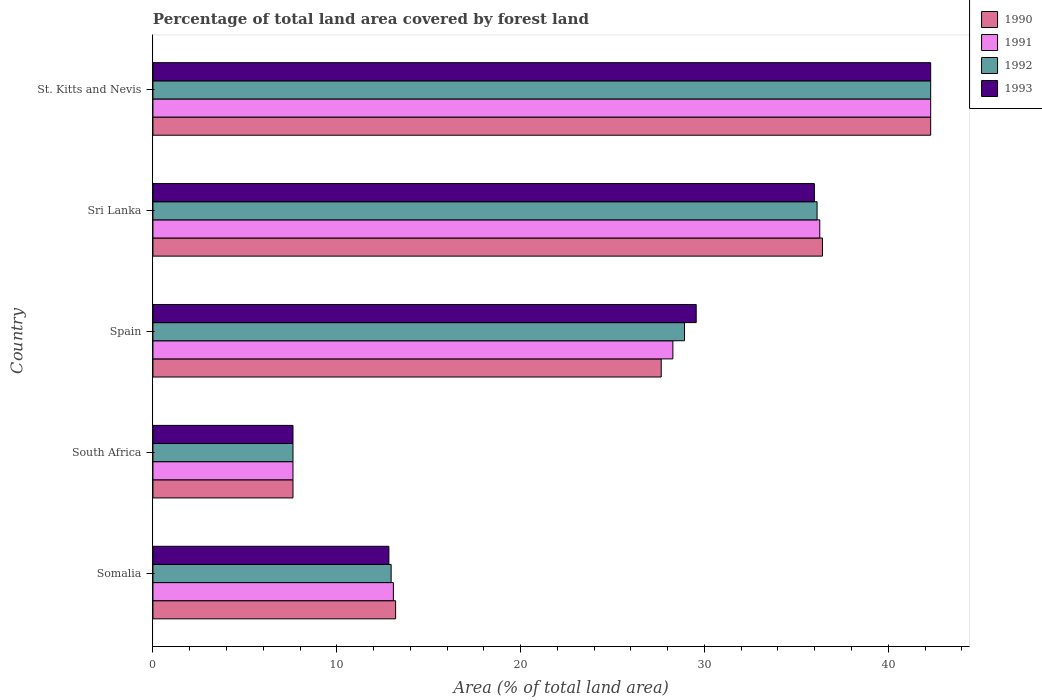How many bars are there on the 3rd tick from the bottom?
Keep it short and to the point. 4. What is the label of the 2nd group of bars from the top?
Your response must be concise. Sri Lanka. In how many cases, is the number of bars for a given country not equal to the number of legend labels?
Provide a succinct answer. 0. What is the percentage of forest land in 1992 in South Africa?
Provide a short and direct response. 7.62. Across all countries, what is the maximum percentage of forest land in 1990?
Give a very brief answer. 42.31. Across all countries, what is the minimum percentage of forest land in 1991?
Your response must be concise. 7.62. In which country was the percentage of forest land in 1990 maximum?
Provide a short and direct response. St. Kitts and Nevis. In which country was the percentage of forest land in 1990 minimum?
Provide a short and direct response. South Africa. What is the total percentage of forest land in 1992 in the graph?
Offer a very short reply. 127.93. What is the difference between the percentage of forest land in 1993 in Sri Lanka and that in St. Kitts and Nevis?
Provide a short and direct response. -6.33. What is the difference between the percentage of forest land in 1992 in Sri Lanka and the percentage of forest land in 1991 in South Africa?
Your answer should be very brief. 28.51. What is the average percentage of forest land in 1990 per country?
Provide a short and direct response. 25.44. What is the difference between the percentage of forest land in 1993 and percentage of forest land in 1990 in Sri Lanka?
Your response must be concise. -0.44. In how many countries, is the percentage of forest land in 1993 greater than 20 %?
Your answer should be very brief. 3. What is the ratio of the percentage of forest land in 1991 in Spain to that in St. Kitts and Nevis?
Give a very brief answer. 0.67. Is the percentage of forest land in 1990 in South Africa less than that in Sri Lanka?
Give a very brief answer. Yes. What is the difference between the highest and the second highest percentage of forest land in 1992?
Offer a very short reply. 6.18. What is the difference between the highest and the lowest percentage of forest land in 1992?
Your answer should be compact. 34.69. In how many countries, is the percentage of forest land in 1990 greater than the average percentage of forest land in 1990 taken over all countries?
Provide a succinct answer. 3. Is the sum of the percentage of forest land in 1992 in South Africa and St. Kitts and Nevis greater than the maximum percentage of forest land in 1993 across all countries?
Provide a succinct answer. Yes. Is it the case that in every country, the sum of the percentage of forest land in 1993 and percentage of forest land in 1991 is greater than the sum of percentage of forest land in 1992 and percentage of forest land in 1990?
Your answer should be very brief. No. What does the 4th bar from the bottom in Sri Lanka represents?
Give a very brief answer. 1993. Is it the case that in every country, the sum of the percentage of forest land in 1991 and percentage of forest land in 1992 is greater than the percentage of forest land in 1993?
Offer a very short reply. Yes. How many bars are there?
Your answer should be compact. 20. How many countries are there in the graph?
Ensure brevity in your answer.  5. What is the difference between two consecutive major ticks on the X-axis?
Give a very brief answer. 10. Are the values on the major ticks of X-axis written in scientific E-notation?
Provide a short and direct response. No. Does the graph contain grids?
Offer a very short reply. No. What is the title of the graph?
Your response must be concise. Percentage of total land area covered by forest land. Does "1971" appear as one of the legend labels in the graph?
Provide a succinct answer. No. What is the label or title of the X-axis?
Ensure brevity in your answer.  Area (% of total land area). What is the label or title of the Y-axis?
Offer a terse response. Country. What is the Area (% of total land area) of 1990 in Somalia?
Offer a terse response. 13.2. What is the Area (% of total land area) of 1991 in Somalia?
Ensure brevity in your answer.  13.08. What is the Area (% of total land area) in 1992 in Somalia?
Keep it short and to the point. 12.96. What is the Area (% of total land area) of 1993 in Somalia?
Your response must be concise. 12.83. What is the Area (% of total land area) in 1990 in South Africa?
Keep it short and to the point. 7.62. What is the Area (% of total land area) of 1991 in South Africa?
Offer a very short reply. 7.62. What is the Area (% of total land area) in 1992 in South Africa?
Make the answer very short. 7.62. What is the Area (% of total land area) of 1993 in South Africa?
Give a very brief answer. 7.62. What is the Area (% of total land area) in 1990 in Spain?
Offer a terse response. 27.65. What is the Area (% of total land area) in 1991 in Spain?
Offer a terse response. 28.28. What is the Area (% of total land area) in 1992 in Spain?
Offer a terse response. 28.92. What is the Area (% of total land area) of 1993 in Spain?
Make the answer very short. 29.55. What is the Area (% of total land area) in 1990 in Sri Lanka?
Provide a succinct answer. 36.42. What is the Area (% of total land area) of 1991 in Sri Lanka?
Give a very brief answer. 36.27. What is the Area (% of total land area) in 1992 in Sri Lanka?
Give a very brief answer. 36.13. What is the Area (% of total land area) in 1993 in Sri Lanka?
Your answer should be compact. 35.98. What is the Area (% of total land area) of 1990 in St. Kitts and Nevis?
Your answer should be compact. 42.31. What is the Area (% of total land area) of 1991 in St. Kitts and Nevis?
Provide a short and direct response. 42.31. What is the Area (% of total land area) in 1992 in St. Kitts and Nevis?
Offer a terse response. 42.31. What is the Area (% of total land area) of 1993 in St. Kitts and Nevis?
Keep it short and to the point. 42.31. Across all countries, what is the maximum Area (% of total land area) of 1990?
Your answer should be compact. 42.31. Across all countries, what is the maximum Area (% of total land area) in 1991?
Your answer should be compact. 42.31. Across all countries, what is the maximum Area (% of total land area) of 1992?
Give a very brief answer. 42.31. Across all countries, what is the maximum Area (% of total land area) of 1993?
Give a very brief answer. 42.31. Across all countries, what is the minimum Area (% of total land area) in 1990?
Provide a succinct answer. 7.62. Across all countries, what is the minimum Area (% of total land area) in 1991?
Offer a very short reply. 7.62. Across all countries, what is the minimum Area (% of total land area) in 1992?
Ensure brevity in your answer.  7.62. Across all countries, what is the minimum Area (% of total land area) of 1993?
Make the answer very short. 7.62. What is the total Area (% of total land area) of 1990 in the graph?
Ensure brevity in your answer.  127.2. What is the total Area (% of total land area) of 1991 in the graph?
Give a very brief answer. 127.56. What is the total Area (% of total land area) in 1992 in the graph?
Give a very brief answer. 127.93. What is the total Area (% of total land area) of 1993 in the graph?
Keep it short and to the point. 128.29. What is the difference between the Area (% of total land area) in 1990 in Somalia and that in South Africa?
Your answer should be very brief. 5.58. What is the difference between the Area (% of total land area) in 1991 in Somalia and that in South Africa?
Provide a succinct answer. 5.46. What is the difference between the Area (% of total land area) in 1992 in Somalia and that in South Africa?
Your answer should be compact. 5.34. What is the difference between the Area (% of total land area) in 1993 in Somalia and that in South Africa?
Provide a short and direct response. 5.22. What is the difference between the Area (% of total land area) in 1990 in Somalia and that in Spain?
Give a very brief answer. -14.45. What is the difference between the Area (% of total land area) in 1991 in Somalia and that in Spain?
Your response must be concise. -15.2. What is the difference between the Area (% of total land area) in 1992 in Somalia and that in Spain?
Ensure brevity in your answer.  -15.96. What is the difference between the Area (% of total land area) in 1993 in Somalia and that in Spain?
Your response must be concise. -16.72. What is the difference between the Area (% of total land area) of 1990 in Somalia and that in Sri Lanka?
Your answer should be very brief. -23.22. What is the difference between the Area (% of total land area) of 1991 in Somalia and that in Sri Lanka?
Make the answer very short. -23.2. What is the difference between the Area (% of total land area) of 1992 in Somalia and that in Sri Lanka?
Offer a terse response. -23.17. What is the difference between the Area (% of total land area) of 1993 in Somalia and that in Sri Lanka?
Your answer should be very brief. -23.15. What is the difference between the Area (% of total land area) in 1990 in Somalia and that in St. Kitts and Nevis?
Your answer should be very brief. -29.11. What is the difference between the Area (% of total land area) of 1991 in Somalia and that in St. Kitts and Nevis?
Offer a terse response. -29.23. What is the difference between the Area (% of total land area) in 1992 in Somalia and that in St. Kitts and Nevis?
Keep it short and to the point. -29.35. What is the difference between the Area (% of total land area) in 1993 in Somalia and that in St. Kitts and Nevis?
Make the answer very short. -29.47. What is the difference between the Area (% of total land area) of 1990 in South Africa and that in Spain?
Your response must be concise. -20.03. What is the difference between the Area (% of total land area) of 1991 in South Africa and that in Spain?
Give a very brief answer. -20.67. What is the difference between the Area (% of total land area) in 1992 in South Africa and that in Spain?
Your answer should be compact. -21.3. What is the difference between the Area (% of total land area) in 1993 in South Africa and that in Spain?
Make the answer very short. -21.93. What is the difference between the Area (% of total land area) of 1990 in South Africa and that in Sri Lanka?
Your answer should be very brief. -28.8. What is the difference between the Area (% of total land area) in 1991 in South Africa and that in Sri Lanka?
Give a very brief answer. -28.66. What is the difference between the Area (% of total land area) in 1992 in South Africa and that in Sri Lanka?
Keep it short and to the point. -28.51. What is the difference between the Area (% of total land area) in 1993 in South Africa and that in Sri Lanka?
Your response must be concise. -28.36. What is the difference between the Area (% of total land area) in 1990 in South Africa and that in St. Kitts and Nevis?
Ensure brevity in your answer.  -34.69. What is the difference between the Area (% of total land area) of 1991 in South Africa and that in St. Kitts and Nevis?
Your answer should be compact. -34.69. What is the difference between the Area (% of total land area) of 1992 in South Africa and that in St. Kitts and Nevis?
Ensure brevity in your answer.  -34.69. What is the difference between the Area (% of total land area) of 1993 in South Africa and that in St. Kitts and Nevis?
Your answer should be compact. -34.69. What is the difference between the Area (% of total land area) in 1990 in Spain and that in Sri Lanka?
Your response must be concise. -8.77. What is the difference between the Area (% of total land area) in 1991 in Spain and that in Sri Lanka?
Offer a very short reply. -7.99. What is the difference between the Area (% of total land area) of 1992 in Spain and that in Sri Lanka?
Make the answer very short. -7.21. What is the difference between the Area (% of total land area) in 1993 in Spain and that in Sri Lanka?
Ensure brevity in your answer.  -6.43. What is the difference between the Area (% of total land area) of 1990 in Spain and that in St. Kitts and Nevis?
Offer a terse response. -14.66. What is the difference between the Area (% of total land area) in 1991 in Spain and that in St. Kitts and Nevis?
Keep it short and to the point. -14.02. What is the difference between the Area (% of total land area) in 1992 in Spain and that in St. Kitts and Nevis?
Your response must be concise. -13.39. What is the difference between the Area (% of total land area) in 1993 in Spain and that in St. Kitts and Nevis?
Offer a terse response. -12.76. What is the difference between the Area (% of total land area) of 1990 in Sri Lanka and that in St. Kitts and Nevis?
Offer a terse response. -5.89. What is the difference between the Area (% of total land area) of 1991 in Sri Lanka and that in St. Kitts and Nevis?
Your answer should be very brief. -6.03. What is the difference between the Area (% of total land area) of 1992 in Sri Lanka and that in St. Kitts and Nevis?
Give a very brief answer. -6.18. What is the difference between the Area (% of total land area) of 1993 in Sri Lanka and that in St. Kitts and Nevis?
Your response must be concise. -6.33. What is the difference between the Area (% of total land area) of 1990 in Somalia and the Area (% of total land area) of 1991 in South Africa?
Make the answer very short. 5.58. What is the difference between the Area (% of total land area) in 1990 in Somalia and the Area (% of total land area) in 1992 in South Africa?
Offer a terse response. 5.58. What is the difference between the Area (% of total land area) in 1990 in Somalia and the Area (% of total land area) in 1993 in South Africa?
Provide a succinct answer. 5.58. What is the difference between the Area (% of total land area) in 1991 in Somalia and the Area (% of total land area) in 1992 in South Africa?
Make the answer very short. 5.46. What is the difference between the Area (% of total land area) of 1991 in Somalia and the Area (% of total land area) of 1993 in South Africa?
Your answer should be very brief. 5.46. What is the difference between the Area (% of total land area) in 1992 in Somalia and the Area (% of total land area) in 1993 in South Africa?
Your answer should be compact. 5.34. What is the difference between the Area (% of total land area) of 1990 in Somalia and the Area (% of total land area) of 1991 in Spain?
Keep it short and to the point. -15.08. What is the difference between the Area (% of total land area) in 1990 in Somalia and the Area (% of total land area) in 1992 in Spain?
Keep it short and to the point. -15.72. What is the difference between the Area (% of total land area) in 1990 in Somalia and the Area (% of total land area) in 1993 in Spain?
Give a very brief answer. -16.35. What is the difference between the Area (% of total land area) of 1991 in Somalia and the Area (% of total land area) of 1992 in Spain?
Keep it short and to the point. -15.84. What is the difference between the Area (% of total land area) of 1991 in Somalia and the Area (% of total land area) of 1993 in Spain?
Offer a very short reply. -16.47. What is the difference between the Area (% of total land area) of 1992 in Somalia and the Area (% of total land area) of 1993 in Spain?
Make the answer very short. -16.6. What is the difference between the Area (% of total land area) of 1990 in Somalia and the Area (% of total land area) of 1991 in Sri Lanka?
Provide a succinct answer. -23.07. What is the difference between the Area (% of total land area) of 1990 in Somalia and the Area (% of total land area) of 1992 in Sri Lanka?
Give a very brief answer. -22.93. What is the difference between the Area (% of total land area) in 1990 in Somalia and the Area (% of total land area) in 1993 in Sri Lanka?
Your response must be concise. -22.78. What is the difference between the Area (% of total land area) in 1991 in Somalia and the Area (% of total land area) in 1992 in Sri Lanka?
Provide a succinct answer. -23.05. What is the difference between the Area (% of total land area) of 1991 in Somalia and the Area (% of total land area) of 1993 in Sri Lanka?
Offer a very short reply. -22.9. What is the difference between the Area (% of total land area) in 1992 in Somalia and the Area (% of total land area) in 1993 in Sri Lanka?
Your response must be concise. -23.02. What is the difference between the Area (% of total land area) in 1990 in Somalia and the Area (% of total land area) in 1991 in St. Kitts and Nevis?
Give a very brief answer. -29.11. What is the difference between the Area (% of total land area) in 1990 in Somalia and the Area (% of total land area) in 1992 in St. Kitts and Nevis?
Make the answer very short. -29.11. What is the difference between the Area (% of total land area) in 1990 in Somalia and the Area (% of total land area) in 1993 in St. Kitts and Nevis?
Provide a succinct answer. -29.11. What is the difference between the Area (% of total land area) of 1991 in Somalia and the Area (% of total land area) of 1992 in St. Kitts and Nevis?
Provide a short and direct response. -29.23. What is the difference between the Area (% of total land area) in 1991 in Somalia and the Area (% of total land area) in 1993 in St. Kitts and Nevis?
Offer a terse response. -29.23. What is the difference between the Area (% of total land area) in 1992 in Somalia and the Area (% of total land area) in 1993 in St. Kitts and Nevis?
Keep it short and to the point. -29.35. What is the difference between the Area (% of total land area) of 1990 in South Africa and the Area (% of total land area) of 1991 in Spain?
Make the answer very short. -20.67. What is the difference between the Area (% of total land area) of 1990 in South Africa and the Area (% of total land area) of 1992 in Spain?
Ensure brevity in your answer.  -21.3. What is the difference between the Area (% of total land area) of 1990 in South Africa and the Area (% of total land area) of 1993 in Spain?
Offer a terse response. -21.93. What is the difference between the Area (% of total land area) in 1991 in South Africa and the Area (% of total land area) in 1992 in Spain?
Provide a short and direct response. -21.3. What is the difference between the Area (% of total land area) in 1991 in South Africa and the Area (% of total land area) in 1993 in Spain?
Ensure brevity in your answer.  -21.93. What is the difference between the Area (% of total land area) in 1992 in South Africa and the Area (% of total land area) in 1993 in Spain?
Make the answer very short. -21.93. What is the difference between the Area (% of total land area) of 1990 in South Africa and the Area (% of total land area) of 1991 in Sri Lanka?
Offer a terse response. -28.66. What is the difference between the Area (% of total land area) of 1990 in South Africa and the Area (% of total land area) of 1992 in Sri Lanka?
Offer a very short reply. -28.51. What is the difference between the Area (% of total land area) in 1990 in South Africa and the Area (% of total land area) in 1993 in Sri Lanka?
Keep it short and to the point. -28.36. What is the difference between the Area (% of total land area) of 1991 in South Africa and the Area (% of total land area) of 1992 in Sri Lanka?
Provide a short and direct response. -28.51. What is the difference between the Area (% of total land area) in 1991 in South Africa and the Area (% of total land area) in 1993 in Sri Lanka?
Provide a succinct answer. -28.36. What is the difference between the Area (% of total land area) in 1992 in South Africa and the Area (% of total land area) in 1993 in Sri Lanka?
Keep it short and to the point. -28.36. What is the difference between the Area (% of total land area) in 1990 in South Africa and the Area (% of total land area) in 1991 in St. Kitts and Nevis?
Ensure brevity in your answer.  -34.69. What is the difference between the Area (% of total land area) in 1990 in South Africa and the Area (% of total land area) in 1992 in St. Kitts and Nevis?
Offer a very short reply. -34.69. What is the difference between the Area (% of total land area) in 1990 in South Africa and the Area (% of total land area) in 1993 in St. Kitts and Nevis?
Your answer should be very brief. -34.69. What is the difference between the Area (% of total land area) in 1991 in South Africa and the Area (% of total land area) in 1992 in St. Kitts and Nevis?
Make the answer very short. -34.69. What is the difference between the Area (% of total land area) in 1991 in South Africa and the Area (% of total land area) in 1993 in St. Kitts and Nevis?
Provide a succinct answer. -34.69. What is the difference between the Area (% of total land area) in 1992 in South Africa and the Area (% of total land area) in 1993 in St. Kitts and Nevis?
Offer a terse response. -34.69. What is the difference between the Area (% of total land area) in 1990 in Spain and the Area (% of total land area) in 1991 in Sri Lanka?
Offer a very short reply. -8.62. What is the difference between the Area (% of total land area) of 1990 in Spain and the Area (% of total land area) of 1992 in Sri Lanka?
Your answer should be very brief. -8.48. What is the difference between the Area (% of total land area) of 1990 in Spain and the Area (% of total land area) of 1993 in Sri Lanka?
Ensure brevity in your answer.  -8.33. What is the difference between the Area (% of total land area) in 1991 in Spain and the Area (% of total land area) in 1992 in Sri Lanka?
Provide a short and direct response. -7.84. What is the difference between the Area (% of total land area) in 1991 in Spain and the Area (% of total land area) in 1993 in Sri Lanka?
Offer a terse response. -7.7. What is the difference between the Area (% of total land area) of 1992 in Spain and the Area (% of total land area) of 1993 in Sri Lanka?
Offer a terse response. -7.06. What is the difference between the Area (% of total land area) in 1990 in Spain and the Area (% of total land area) in 1991 in St. Kitts and Nevis?
Ensure brevity in your answer.  -14.66. What is the difference between the Area (% of total land area) in 1990 in Spain and the Area (% of total land area) in 1992 in St. Kitts and Nevis?
Keep it short and to the point. -14.66. What is the difference between the Area (% of total land area) of 1990 in Spain and the Area (% of total land area) of 1993 in St. Kitts and Nevis?
Offer a terse response. -14.66. What is the difference between the Area (% of total land area) in 1991 in Spain and the Area (% of total land area) in 1992 in St. Kitts and Nevis?
Your answer should be very brief. -14.02. What is the difference between the Area (% of total land area) of 1991 in Spain and the Area (% of total land area) of 1993 in St. Kitts and Nevis?
Your answer should be very brief. -14.02. What is the difference between the Area (% of total land area) in 1992 in Spain and the Area (% of total land area) in 1993 in St. Kitts and Nevis?
Provide a succinct answer. -13.39. What is the difference between the Area (% of total land area) in 1990 in Sri Lanka and the Area (% of total land area) in 1991 in St. Kitts and Nevis?
Provide a short and direct response. -5.89. What is the difference between the Area (% of total land area) in 1990 in Sri Lanka and the Area (% of total land area) in 1992 in St. Kitts and Nevis?
Your response must be concise. -5.89. What is the difference between the Area (% of total land area) of 1990 in Sri Lanka and the Area (% of total land area) of 1993 in St. Kitts and Nevis?
Ensure brevity in your answer.  -5.89. What is the difference between the Area (% of total land area) in 1991 in Sri Lanka and the Area (% of total land area) in 1992 in St. Kitts and Nevis?
Keep it short and to the point. -6.03. What is the difference between the Area (% of total land area) of 1991 in Sri Lanka and the Area (% of total land area) of 1993 in St. Kitts and Nevis?
Give a very brief answer. -6.03. What is the difference between the Area (% of total land area) of 1992 in Sri Lanka and the Area (% of total land area) of 1993 in St. Kitts and Nevis?
Provide a short and direct response. -6.18. What is the average Area (% of total land area) of 1990 per country?
Your answer should be compact. 25.44. What is the average Area (% of total land area) in 1991 per country?
Give a very brief answer. 25.51. What is the average Area (% of total land area) of 1992 per country?
Your answer should be very brief. 25.59. What is the average Area (% of total land area) of 1993 per country?
Your answer should be compact. 25.66. What is the difference between the Area (% of total land area) in 1990 and Area (% of total land area) in 1991 in Somalia?
Ensure brevity in your answer.  0.12. What is the difference between the Area (% of total land area) in 1990 and Area (% of total land area) in 1992 in Somalia?
Give a very brief answer. 0.24. What is the difference between the Area (% of total land area) in 1990 and Area (% of total land area) in 1993 in Somalia?
Make the answer very short. 0.37. What is the difference between the Area (% of total land area) of 1991 and Area (% of total land area) of 1992 in Somalia?
Offer a very short reply. 0.12. What is the difference between the Area (% of total land area) of 1991 and Area (% of total land area) of 1993 in Somalia?
Provide a succinct answer. 0.24. What is the difference between the Area (% of total land area) of 1992 and Area (% of total land area) of 1993 in Somalia?
Ensure brevity in your answer.  0.12. What is the difference between the Area (% of total land area) of 1990 and Area (% of total land area) of 1991 in South Africa?
Keep it short and to the point. 0. What is the difference between the Area (% of total land area) of 1990 and Area (% of total land area) of 1991 in Spain?
Keep it short and to the point. -0.63. What is the difference between the Area (% of total land area) in 1990 and Area (% of total land area) in 1992 in Spain?
Provide a short and direct response. -1.27. What is the difference between the Area (% of total land area) of 1990 and Area (% of total land area) of 1993 in Spain?
Offer a very short reply. -1.9. What is the difference between the Area (% of total land area) in 1991 and Area (% of total land area) in 1992 in Spain?
Give a very brief answer. -0.63. What is the difference between the Area (% of total land area) of 1991 and Area (% of total land area) of 1993 in Spain?
Provide a succinct answer. -1.27. What is the difference between the Area (% of total land area) of 1992 and Area (% of total land area) of 1993 in Spain?
Offer a terse response. -0.63. What is the difference between the Area (% of total land area) of 1990 and Area (% of total land area) of 1991 in Sri Lanka?
Ensure brevity in your answer.  0.15. What is the difference between the Area (% of total land area) in 1990 and Area (% of total land area) in 1992 in Sri Lanka?
Keep it short and to the point. 0.29. What is the difference between the Area (% of total land area) in 1990 and Area (% of total land area) in 1993 in Sri Lanka?
Offer a very short reply. 0.44. What is the difference between the Area (% of total land area) in 1991 and Area (% of total land area) in 1992 in Sri Lanka?
Make the answer very short. 0.15. What is the difference between the Area (% of total land area) of 1991 and Area (% of total land area) of 1993 in Sri Lanka?
Make the answer very short. 0.29. What is the difference between the Area (% of total land area) in 1992 and Area (% of total land area) in 1993 in Sri Lanka?
Offer a very short reply. 0.15. What is the difference between the Area (% of total land area) in 1990 and Area (% of total land area) in 1993 in St. Kitts and Nevis?
Your answer should be very brief. 0. What is the difference between the Area (% of total land area) in 1991 and Area (% of total land area) in 1992 in St. Kitts and Nevis?
Offer a very short reply. 0. What is the ratio of the Area (% of total land area) of 1990 in Somalia to that in South Africa?
Provide a succinct answer. 1.73. What is the ratio of the Area (% of total land area) of 1991 in Somalia to that in South Africa?
Offer a terse response. 1.72. What is the ratio of the Area (% of total land area) in 1992 in Somalia to that in South Africa?
Provide a short and direct response. 1.7. What is the ratio of the Area (% of total land area) of 1993 in Somalia to that in South Africa?
Keep it short and to the point. 1.68. What is the ratio of the Area (% of total land area) in 1990 in Somalia to that in Spain?
Your answer should be compact. 0.48. What is the ratio of the Area (% of total land area) of 1991 in Somalia to that in Spain?
Keep it short and to the point. 0.46. What is the ratio of the Area (% of total land area) of 1992 in Somalia to that in Spain?
Offer a very short reply. 0.45. What is the ratio of the Area (% of total land area) of 1993 in Somalia to that in Spain?
Your answer should be compact. 0.43. What is the ratio of the Area (% of total land area) in 1990 in Somalia to that in Sri Lanka?
Your response must be concise. 0.36. What is the ratio of the Area (% of total land area) of 1991 in Somalia to that in Sri Lanka?
Offer a terse response. 0.36. What is the ratio of the Area (% of total land area) of 1992 in Somalia to that in Sri Lanka?
Provide a short and direct response. 0.36. What is the ratio of the Area (% of total land area) in 1993 in Somalia to that in Sri Lanka?
Offer a very short reply. 0.36. What is the ratio of the Area (% of total land area) of 1990 in Somalia to that in St. Kitts and Nevis?
Offer a very short reply. 0.31. What is the ratio of the Area (% of total land area) of 1991 in Somalia to that in St. Kitts and Nevis?
Keep it short and to the point. 0.31. What is the ratio of the Area (% of total land area) of 1992 in Somalia to that in St. Kitts and Nevis?
Offer a terse response. 0.31. What is the ratio of the Area (% of total land area) in 1993 in Somalia to that in St. Kitts and Nevis?
Offer a terse response. 0.3. What is the ratio of the Area (% of total land area) in 1990 in South Africa to that in Spain?
Your answer should be very brief. 0.28. What is the ratio of the Area (% of total land area) in 1991 in South Africa to that in Spain?
Your response must be concise. 0.27. What is the ratio of the Area (% of total land area) of 1992 in South Africa to that in Spain?
Provide a succinct answer. 0.26. What is the ratio of the Area (% of total land area) of 1993 in South Africa to that in Spain?
Offer a terse response. 0.26. What is the ratio of the Area (% of total land area) in 1990 in South Africa to that in Sri Lanka?
Ensure brevity in your answer.  0.21. What is the ratio of the Area (% of total land area) in 1991 in South Africa to that in Sri Lanka?
Offer a terse response. 0.21. What is the ratio of the Area (% of total land area) in 1992 in South Africa to that in Sri Lanka?
Keep it short and to the point. 0.21. What is the ratio of the Area (% of total land area) of 1993 in South Africa to that in Sri Lanka?
Provide a short and direct response. 0.21. What is the ratio of the Area (% of total land area) in 1990 in South Africa to that in St. Kitts and Nevis?
Provide a succinct answer. 0.18. What is the ratio of the Area (% of total land area) of 1991 in South Africa to that in St. Kitts and Nevis?
Ensure brevity in your answer.  0.18. What is the ratio of the Area (% of total land area) of 1992 in South Africa to that in St. Kitts and Nevis?
Your response must be concise. 0.18. What is the ratio of the Area (% of total land area) in 1993 in South Africa to that in St. Kitts and Nevis?
Keep it short and to the point. 0.18. What is the ratio of the Area (% of total land area) in 1990 in Spain to that in Sri Lanka?
Your response must be concise. 0.76. What is the ratio of the Area (% of total land area) of 1991 in Spain to that in Sri Lanka?
Make the answer very short. 0.78. What is the ratio of the Area (% of total land area) in 1992 in Spain to that in Sri Lanka?
Provide a short and direct response. 0.8. What is the ratio of the Area (% of total land area) of 1993 in Spain to that in Sri Lanka?
Provide a succinct answer. 0.82. What is the ratio of the Area (% of total land area) of 1990 in Spain to that in St. Kitts and Nevis?
Your response must be concise. 0.65. What is the ratio of the Area (% of total land area) in 1991 in Spain to that in St. Kitts and Nevis?
Your answer should be very brief. 0.67. What is the ratio of the Area (% of total land area) of 1992 in Spain to that in St. Kitts and Nevis?
Your answer should be very brief. 0.68. What is the ratio of the Area (% of total land area) of 1993 in Spain to that in St. Kitts and Nevis?
Provide a succinct answer. 0.7. What is the ratio of the Area (% of total land area) of 1990 in Sri Lanka to that in St. Kitts and Nevis?
Keep it short and to the point. 0.86. What is the ratio of the Area (% of total land area) in 1991 in Sri Lanka to that in St. Kitts and Nevis?
Offer a terse response. 0.86. What is the ratio of the Area (% of total land area) of 1992 in Sri Lanka to that in St. Kitts and Nevis?
Provide a succinct answer. 0.85. What is the ratio of the Area (% of total land area) in 1993 in Sri Lanka to that in St. Kitts and Nevis?
Offer a terse response. 0.85. What is the difference between the highest and the second highest Area (% of total land area) of 1990?
Make the answer very short. 5.89. What is the difference between the highest and the second highest Area (% of total land area) of 1991?
Offer a very short reply. 6.03. What is the difference between the highest and the second highest Area (% of total land area) of 1992?
Your response must be concise. 6.18. What is the difference between the highest and the second highest Area (% of total land area) of 1993?
Provide a short and direct response. 6.33. What is the difference between the highest and the lowest Area (% of total land area) of 1990?
Make the answer very short. 34.69. What is the difference between the highest and the lowest Area (% of total land area) in 1991?
Give a very brief answer. 34.69. What is the difference between the highest and the lowest Area (% of total land area) in 1992?
Give a very brief answer. 34.69. What is the difference between the highest and the lowest Area (% of total land area) of 1993?
Make the answer very short. 34.69. 